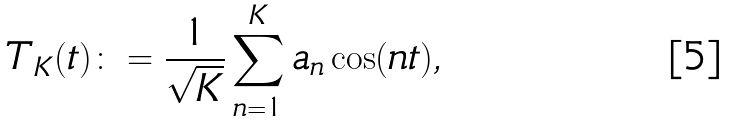Convert formula to latex. <formula><loc_0><loc_0><loc_500><loc_500>T _ { K } ( t ) \colon = \frac { 1 } { \sqrt { K } } \sum ^ { K } _ { n = 1 } a _ { n } \cos ( n t ) ,</formula> 